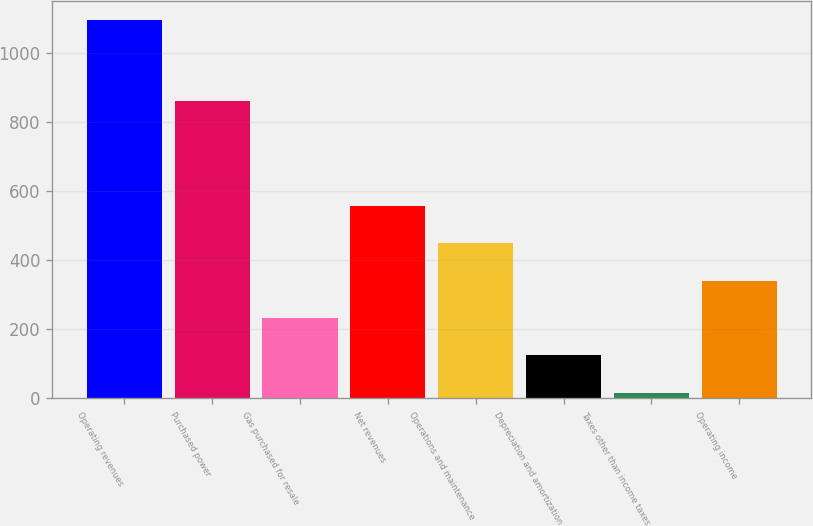<chart> <loc_0><loc_0><loc_500><loc_500><bar_chart><fcel>Operating revenues<fcel>Purchased power<fcel>Gas purchased for resale<fcel>Net revenues<fcel>Operations and maintenance<fcel>Depreciation and amortization<fcel>Taxes other than income taxes<fcel>Operating income<nl><fcel>1096<fcel>861<fcel>232.8<fcel>556.5<fcel>448.6<fcel>124.9<fcel>17<fcel>340.7<nl></chart> 